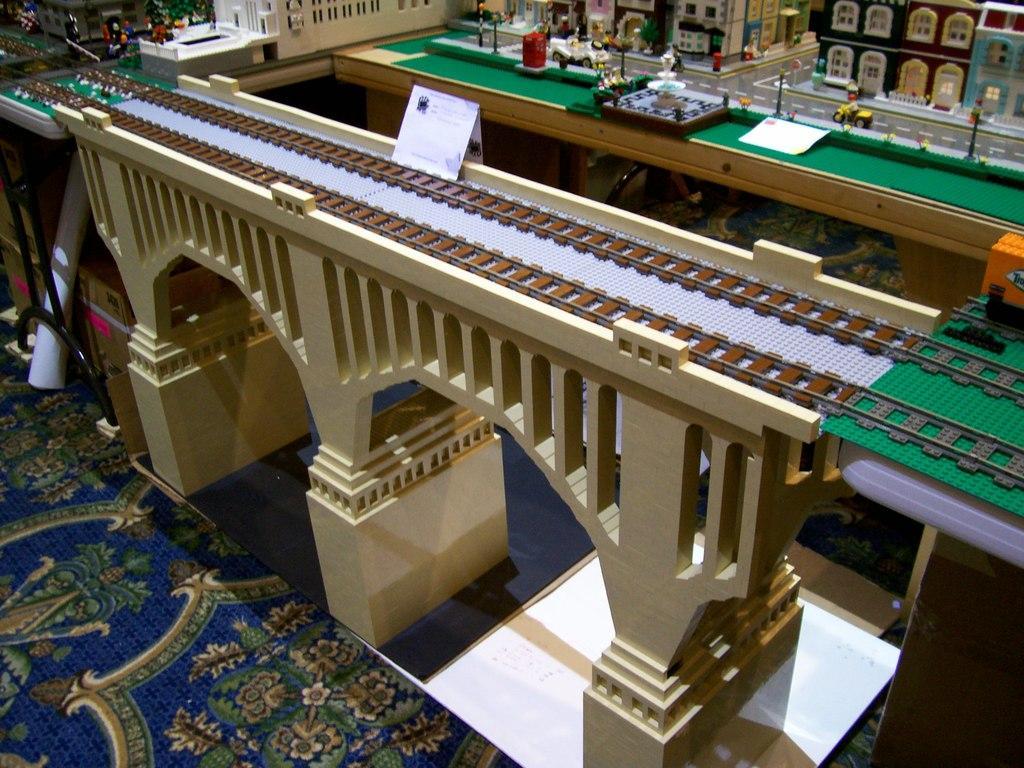How would you summarize this image in a sentence or two? In this image I can see a miniature of the bridge, railway track, fountain, buildings, windows, vehicles, poles and few objects. They are on the surface. 